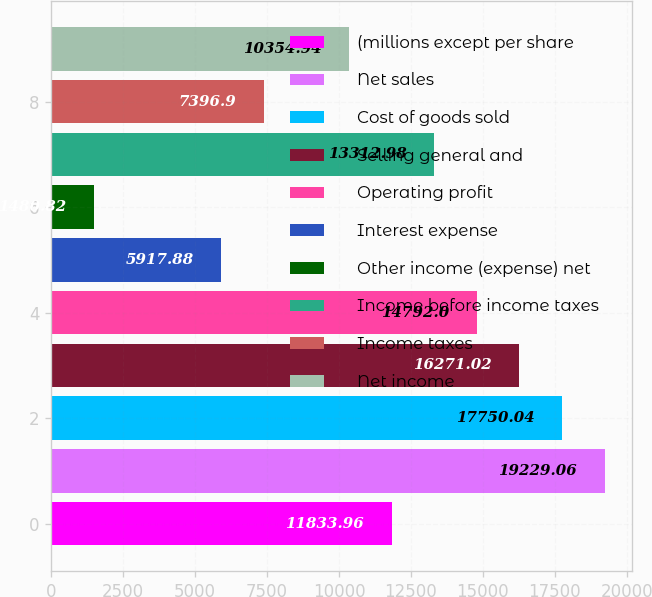Convert chart to OTSL. <chart><loc_0><loc_0><loc_500><loc_500><bar_chart><fcel>(millions except per share<fcel>Net sales<fcel>Cost of goods sold<fcel>Selling general and<fcel>Operating profit<fcel>Interest expense<fcel>Other income (expense) net<fcel>Income before income taxes<fcel>Income taxes<fcel>Net income<nl><fcel>11834<fcel>19229.1<fcel>17750<fcel>16271<fcel>14792<fcel>5917.88<fcel>1480.82<fcel>13313<fcel>7396.9<fcel>10354.9<nl></chart> 